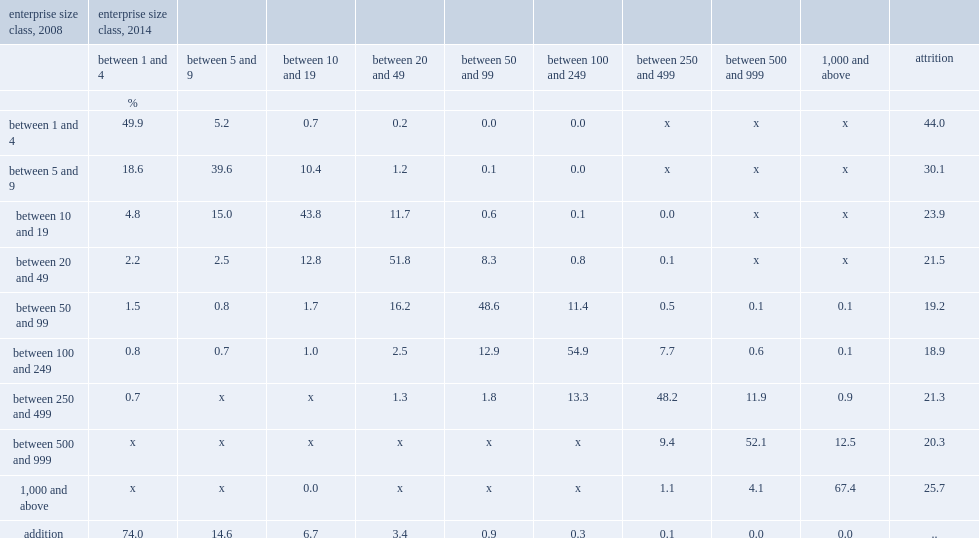Which enterprise size class in 2014 constitutes the largest proportion of enterprises in 2014 service sector that did not exist in 2008 service sector? Between 1 and 4. 